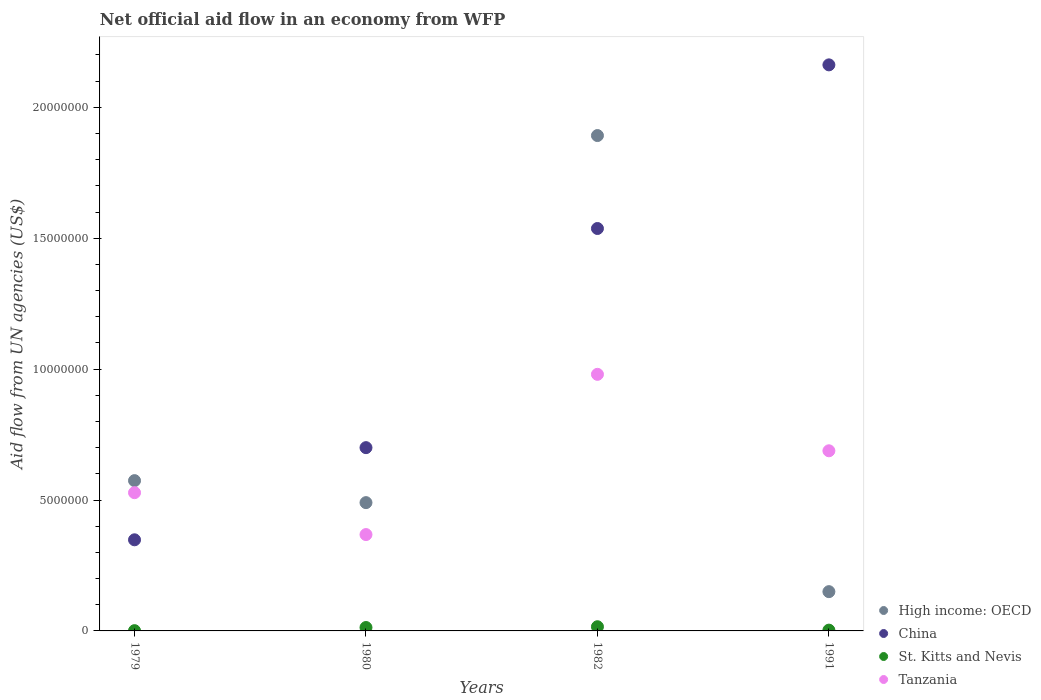How many different coloured dotlines are there?
Provide a succinct answer. 4. Is the number of dotlines equal to the number of legend labels?
Keep it short and to the point. Yes. What is the net official aid flow in China in 1991?
Make the answer very short. 2.16e+07. Across all years, what is the maximum net official aid flow in High income: OECD?
Ensure brevity in your answer.  1.89e+07. What is the total net official aid flow in Tanzania in the graph?
Your response must be concise. 2.56e+07. What is the difference between the net official aid flow in High income: OECD in 1979 and that in 1980?
Provide a succinct answer. 8.40e+05. What is the difference between the net official aid flow in High income: OECD in 1979 and the net official aid flow in China in 1980?
Your response must be concise. -1.26e+06. What is the average net official aid flow in China per year?
Offer a very short reply. 1.19e+07. In the year 1980, what is the difference between the net official aid flow in China and net official aid flow in High income: OECD?
Offer a terse response. 2.10e+06. In how many years, is the net official aid flow in St. Kitts and Nevis greater than 15000000 US$?
Make the answer very short. 0. What is the ratio of the net official aid flow in High income: OECD in 1980 to that in 1982?
Offer a terse response. 0.26. Is the difference between the net official aid flow in China in 1979 and 1982 greater than the difference between the net official aid flow in High income: OECD in 1979 and 1982?
Offer a terse response. Yes. What is the difference between the highest and the second highest net official aid flow in Tanzania?
Provide a short and direct response. 2.92e+06. What is the difference between the highest and the lowest net official aid flow in High income: OECD?
Your answer should be very brief. 1.74e+07. Is the sum of the net official aid flow in High income: OECD in 1982 and 1991 greater than the maximum net official aid flow in Tanzania across all years?
Ensure brevity in your answer.  Yes. Is it the case that in every year, the sum of the net official aid flow in St. Kitts and Nevis and net official aid flow in High income: OECD  is greater than the sum of net official aid flow in China and net official aid flow in Tanzania?
Your answer should be compact. No. Is it the case that in every year, the sum of the net official aid flow in High income: OECD and net official aid flow in Tanzania  is greater than the net official aid flow in China?
Provide a succinct answer. No. Does the net official aid flow in High income: OECD monotonically increase over the years?
Provide a short and direct response. No. How many dotlines are there?
Provide a short and direct response. 4. How many years are there in the graph?
Provide a succinct answer. 4. What is the difference between two consecutive major ticks on the Y-axis?
Your response must be concise. 5.00e+06. Where does the legend appear in the graph?
Make the answer very short. Bottom right. How are the legend labels stacked?
Provide a succinct answer. Vertical. What is the title of the graph?
Provide a short and direct response. Net official aid flow in an economy from WFP. What is the label or title of the X-axis?
Offer a terse response. Years. What is the label or title of the Y-axis?
Offer a very short reply. Aid flow from UN agencies (US$). What is the Aid flow from UN agencies (US$) of High income: OECD in 1979?
Ensure brevity in your answer.  5.74e+06. What is the Aid flow from UN agencies (US$) of China in 1979?
Provide a short and direct response. 3.48e+06. What is the Aid flow from UN agencies (US$) of Tanzania in 1979?
Keep it short and to the point. 5.28e+06. What is the Aid flow from UN agencies (US$) of High income: OECD in 1980?
Offer a terse response. 4.90e+06. What is the Aid flow from UN agencies (US$) of Tanzania in 1980?
Your answer should be compact. 3.68e+06. What is the Aid flow from UN agencies (US$) of High income: OECD in 1982?
Give a very brief answer. 1.89e+07. What is the Aid flow from UN agencies (US$) of China in 1982?
Your answer should be very brief. 1.54e+07. What is the Aid flow from UN agencies (US$) in St. Kitts and Nevis in 1982?
Offer a terse response. 1.60e+05. What is the Aid flow from UN agencies (US$) in Tanzania in 1982?
Provide a succinct answer. 9.80e+06. What is the Aid flow from UN agencies (US$) of High income: OECD in 1991?
Give a very brief answer. 1.50e+06. What is the Aid flow from UN agencies (US$) in China in 1991?
Provide a succinct answer. 2.16e+07. What is the Aid flow from UN agencies (US$) in St. Kitts and Nevis in 1991?
Keep it short and to the point. 3.00e+04. What is the Aid flow from UN agencies (US$) of Tanzania in 1991?
Your answer should be compact. 6.88e+06. Across all years, what is the maximum Aid flow from UN agencies (US$) in High income: OECD?
Your response must be concise. 1.89e+07. Across all years, what is the maximum Aid flow from UN agencies (US$) of China?
Provide a succinct answer. 2.16e+07. Across all years, what is the maximum Aid flow from UN agencies (US$) in St. Kitts and Nevis?
Provide a succinct answer. 1.60e+05. Across all years, what is the maximum Aid flow from UN agencies (US$) of Tanzania?
Give a very brief answer. 9.80e+06. Across all years, what is the minimum Aid flow from UN agencies (US$) in High income: OECD?
Offer a terse response. 1.50e+06. Across all years, what is the minimum Aid flow from UN agencies (US$) of China?
Give a very brief answer. 3.48e+06. Across all years, what is the minimum Aid flow from UN agencies (US$) of St. Kitts and Nevis?
Provide a succinct answer. 10000. Across all years, what is the minimum Aid flow from UN agencies (US$) of Tanzania?
Your response must be concise. 3.68e+06. What is the total Aid flow from UN agencies (US$) of High income: OECD in the graph?
Make the answer very short. 3.11e+07. What is the total Aid flow from UN agencies (US$) in China in the graph?
Keep it short and to the point. 4.75e+07. What is the total Aid flow from UN agencies (US$) of Tanzania in the graph?
Make the answer very short. 2.56e+07. What is the difference between the Aid flow from UN agencies (US$) of High income: OECD in 1979 and that in 1980?
Provide a short and direct response. 8.40e+05. What is the difference between the Aid flow from UN agencies (US$) in China in 1979 and that in 1980?
Make the answer very short. -3.52e+06. What is the difference between the Aid flow from UN agencies (US$) in Tanzania in 1979 and that in 1980?
Provide a succinct answer. 1.60e+06. What is the difference between the Aid flow from UN agencies (US$) in High income: OECD in 1979 and that in 1982?
Offer a very short reply. -1.32e+07. What is the difference between the Aid flow from UN agencies (US$) in China in 1979 and that in 1982?
Your answer should be very brief. -1.19e+07. What is the difference between the Aid flow from UN agencies (US$) of St. Kitts and Nevis in 1979 and that in 1982?
Ensure brevity in your answer.  -1.50e+05. What is the difference between the Aid flow from UN agencies (US$) of Tanzania in 1979 and that in 1982?
Your answer should be compact. -4.52e+06. What is the difference between the Aid flow from UN agencies (US$) in High income: OECD in 1979 and that in 1991?
Offer a very short reply. 4.24e+06. What is the difference between the Aid flow from UN agencies (US$) in China in 1979 and that in 1991?
Make the answer very short. -1.81e+07. What is the difference between the Aid flow from UN agencies (US$) in Tanzania in 1979 and that in 1991?
Keep it short and to the point. -1.60e+06. What is the difference between the Aid flow from UN agencies (US$) of High income: OECD in 1980 and that in 1982?
Ensure brevity in your answer.  -1.40e+07. What is the difference between the Aid flow from UN agencies (US$) of China in 1980 and that in 1982?
Your answer should be compact. -8.37e+06. What is the difference between the Aid flow from UN agencies (US$) in St. Kitts and Nevis in 1980 and that in 1982?
Offer a very short reply. -3.00e+04. What is the difference between the Aid flow from UN agencies (US$) of Tanzania in 1980 and that in 1982?
Provide a short and direct response. -6.12e+06. What is the difference between the Aid flow from UN agencies (US$) in High income: OECD in 1980 and that in 1991?
Ensure brevity in your answer.  3.40e+06. What is the difference between the Aid flow from UN agencies (US$) in China in 1980 and that in 1991?
Provide a short and direct response. -1.46e+07. What is the difference between the Aid flow from UN agencies (US$) in Tanzania in 1980 and that in 1991?
Keep it short and to the point. -3.20e+06. What is the difference between the Aid flow from UN agencies (US$) in High income: OECD in 1982 and that in 1991?
Your response must be concise. 1.74e+07. What is the difference between the Aid flow from UN agencies (US$) of China in 1982 and that in 1991?
Your response must be concise. -6.25e+06. What is the difference between the Aid flow from UN agencies (US$) of St. Kitts and Nevis in 1982 and that in 1991?
Make the answer very short. 1.30e+05. What is the difference between the Aid flow from UN agencies (US$) in Tanzania in 1982 and that in 1991?
Your response must be concise. 2.92e+06. What is the difference between the Aid flow from UN agencies (US$) of High income: OECD in 1979 and the Aid flow from UN agencies (US$) of China in 1980?
Offer a very short reply. -1.26e+06. What is the difference between the Aid flow from UN agencies (US$) of High income: OECD in 1979 and the Aid flow from UN agencies (US$) of St. Kitts and Nevis in 1980?
Provide a short and direct response. 5.61e+06. What is the difference between the Aid flow from UN agencies (US$) in High income: OECD in 1979 and the Aid flow from UN agencies (US$) in Tanzania in 1980?
Offer a terse response. 2.06e+06. What is the difference between the Aid flow from UN agencies (US$) of China in 1979 and the Aid flow from UN agencies (US$) of St. Kitts and Nevis in 1980?
Give a very brief answer. 3.35e+06. What is the difference between the Aid flow from UN agencies (US$) of St. Kitts and Nevis in 1979 and the Aid flow from UN agencies (US$) of Tanzania in 1980?
Keep it short and to the point. -3.67e+06. What is the difference between the Aid flow from UN agencies (US$) in High income: OECD in 1979 and the Aid flow from UN agencies (US$) in China in 1982?
Give a very brief answer. -9.63e+06. What is the difference between the Aid flow from UN agencies (US$) of High income: OECD in 1979 and the Aid flow from UN agencies (US$) of St. Kitts and Nevis in 1982?
Your response must be concise. 5.58e+06. What is the difference between the Aid flow from UN agencies (US$) in High income: OECD in 1979 and the Aid flow from UN agencies (US$) in Tanzania in 1982?
Offer a terse response. -4.06e+06. What is the difference between the Aid flow from UN agencies (US$) in China in 1979 and the Aid flow from UN agencies (US$) in St. Kitts and Nevis in 1982?
Your answer should be compact. 3.32e+06. What is the difference between the Aid flow from UN agencies (US$) in China in 1979 and the Aid flow from UN agencies (US$) in Tanzania in 1982?
Provide a short and direct response. -6.32e+06. What is the difference between the Aid flow from UN agencies (US$) of St. Kitts and Nevis in 1979 and the Aid flow from UN agencies (US$) of Tanzania in 1982?
Make the answer very short. -9.79e+06. What is the difference between the Aid flow from UN agencies (US$) of High income: OECD in 1979 and the Aid flow from UN agencies (US$) of China in 1991?
Your answer should be very brief. -1.59e+07. What is the difference between the Aid flow from UN agencies (US$) of High income: OECD in 1979 and the Aid flow from UN agencies (US$) of St. Kitts and Nevis in 1991?
Keep it short and to the point. 5.71e+06. What is the difference between the Aid flow from UN agencies (US$) in High income: OECD in 1979 and the Aid flow from UN agencies (US$) in Tanzania in 1991?
Ensure brevity in your answer.  -1.14e+06. What is the difference between the Aid flow from UN agencies (US$) in China in 1979 and the Aid flow from UN agencies (US$) in St. Kitts and Nevis in 1991?
Keep it short and to the point. 3.45e+06. What is the difference between the Aid flow from UN agencies (US$) of China in 1979 and the Aid flow from UN agencies (US$) of Tanzania in 1991?
Give a very brief answer. -3.40e+06. What is the difference between the Aid flow from UN agencies (US$) in St. Kitts and Nevis in 1979 and the Aid flow from UN agencies (US$) in Tanzania in 1991?
Give a very brief answer. -6.87e+06. What is the difference between the Aid flow from UN agencies (US$) of High income: OECD in 1980 and the Aid flow from UN agencies (US$) of China in 1982?
Your response must be concise. -1.05e+07. What is the difference between the Aid flow from UN agencies (US$) in High income: OECD in 1980 and the Aid flow from UN agencies (US$) in St. Kitts and Nevis in 1982?
Keep it short and to the point. 4.74e+06. What is the difference between the Aid flow from UN agencies (US$) of High income: OECD in 1980 and the Aid flow from UN agencies (US$) of Tanzania in 1982?
Provide a short and direct response. -4.90e+06. What is the difference between the Aid flow from UN agencies (US$) in China in 1980 and the Aid flow from UN agencies (US$) in St. Kitts and Nevis in 1982?
Provide a short and direct response. 6.84e+06. What is the difference between the Aid flow from UN agencies (US$) in China in 1980 and the Aid flow from UN agencies (US$) in Tanzania in 1982?
Offer a very short reply. -2.80e+06. What is the difference between the Aid flow from UN agencies (US$) of St. Kitts and Nevis in 1980 and the Aid flow from UN agencies (US$) of Tanzania in 1982?
Your answer should be very brief. -9.67e+06. What is the difference between the Aid flow from UN agencies (US$) in High income: OECD in 1980 and the Aid flow from UN agencies (US$) in China in 1991?
Give a very brief answer. -1.67e+07. What is the difference between the Aid flow from UN agencies (US$) in High income: OECD in 1980 and the Aid flow from UN agencies (US$) in St. Kitts and Nevis in 1991?
Offer a very short reply. 4.87e+06. What is the difference between the Aid flow from UN agencies (US$) of High income: OECD in 1980 and the Aid flow from UN agencies (US$) of Tanzania in 1991?
Give a very brief answer. -1.98e+06. What is the difference between the Aid flow from UN agencies (US$) in China in 1980 and the Aid flow from UN agencies (US$) in St. Kitts and Nevis in 1991?
Your response must be concise. 6.97e+06. What is the difference between the Aid flow from UN agencies (US$) of St. Kitts and Nevis in 1980 and the Aid flow from UN agencies (US$) of Tanzania in 1991?
Make the answer very short. -6.75e+06. What is the difference between the Aid flow from UN agencies (US$) in High income: OECD in 1982 and the Aid flow from UN agencies (US$) in China in 1991?
Keep it short and to the point. -2.70e+06. What is the difference between the Aid flow from UN agencies (US$) of High income: OECD in 1982 and the Aid flow from UN agencies (US$) of St. Kitts and Nevis in 1991?
Keep it short and to the point. 1.89e+07. What is the difference between the Aid flow from UN agencies (US$) of High income: OECD in 1982 and the Aid flow from UN agencies (US$) of Tanzania in 1991?
Your response must be concise. 1.20e+07. What is the difference between the Aid flow from UN agencies (US$) in China in 1982 and the Aid flow from UN agencies (US$) in St. Kitts and Nevis in 1991?
Ensure brevity in your answer.  1.53e+07. What is the difference between the Aid flow from UN agencies (US$) of China in 1982 and the Aid flow from UN agencies (US$) of Tanzania in 1991?
Give a very brief answer. 8.49e+06. What is the difference between the Aid flow from UN agencies (US$) in St. Kitts and Nevis in 1982 and the Aid flow from UN agencies (US$) in Tanzania in 1991?
Offer a very short reply. -6.72e+06. What is the average Aid flow from UN agencies (US$) in High income: OECD per year?
Your answer should be compact. 7.76e+06. What is the average Aid flow from UN agencies (US$) of China per year?
Provide a succinct answer. 1.19e+07. What is the average Aid flow from UN agencies (US$) in St. Kitts and Nevis per year?
Make the answer very short. 8.25e+04. What is the average Aid flow from UN agencies (US$) of Tanzania per year?
Keep it short and to the point. 6.41e+06. In the year 1979, what is the difference between the Aid flow from UN agencies (US$) in High income: OECD and Aid flow from UN agencies (US$) in China?
Your answer should be very brief. 2.26e+06. In the year 1979, what is the difference between the Aid flow from UN agencies (US$) in High income: OECD and Aid flow from UN agencies (US$) in St. Kitts and Nevis?
Provide a short and direct response. 5.73e+06. In the year 1979, what is the difference between the Aid flow from UN agencies (US$) in China and Aid flow from UN agencies (US$) in St. Kitts and Nevis?
Your answer should be compact. 3.47e+06. In the year 1979, what is the difference between the Aid flow from UN agencies (US$) of China and Aid flow from UN agencies (US$) of Tanzania?
Provide a short and direct response. -1.80e+06. In the year 1979, what is the difference between the Aid flow from UN agencies (US$) of St. Kitts and Nevis and Aid flow from UN agencies (US$) of Tanzania?
Ensure brevity in your answer.  -5.27e+06. In the year 1980, what is the difference between the Aid flow from UN agencies (US$) of High income: OECD and Aid flow from UN agencies (US$) of China?
Offer a terse response. -2.10e+06. In the year 1980, what is the difference between the Aid flow from UN agencies (US$) of High income: OECD and Aid flow from UN agencies (US$) of St. Kitts and Nevis?
Provide a succinct answer. 4.77e+06. In the year 1980, what is the difference between the Aid flow from UN agencies (US$) in High income: OECD and Aid flow from UN agencies (US$) in Tanzania?
Make the answer very short. 1.22e+06. In the year 1980, what is the difference between the Aid flow from UN agencies (US$) in China and Aid flow from UN agencies (US$) in St. Kitts and Nevis?
Make the answer very short. 6.87e+06. In the year 1980, what is the difference between the Aid flow from UN agencies (US$) of China and Aid flow from UN agencies (US$) of Tanzania?
Provide a short and direct response. 3.32e+06. In the year 1980, what is the difference between the Aid flow from UN agencies (US$) in St. Kitts and Nevis and Aid flow from UN agencies (US$) in Tanzania?
Give a very brief answer. -3.55e+06. In the year 1982, what is the difference between the Aid flow from UN agencies (US$) of High income: OECD and Aid flow from UN agencies (US$) of China?
Offer a terse response. 3.55e+06. In the year 1982, what is the difference between the Aid flow from UN agencies (US$) in High income: OECD and Aid flow from UN agencies (US$) in St. Kitts and Nevis?
Keep it short and to the point. 1.88e+07. In the year 1982, what is the difference between the Aid flow from UN agencies (US$) of High income: OECD and Aid flow from UN agencies (US$) of Tanzania?
Offer a very short reply. 9.12e+06. In the year 1982, what is the difference between the Aid flow from UN agencies (US$) of China and Aid flow from UN agencies (US$) of St. Kitts and Nevis?
Provide a succinct answer. 1.52e+07. In the year 1982, what is the difference between the Aid flow from UN agencies (US$) of China and Aid flow from UN agencies (US$) of Tanzania?
Provide a succinct answer. 5.57e+06. In the year 1982, what is the difference between the Aid flow from UN agencies (US$) in St. Kitts and Nevis and Aid flow from UN agencies (US$) in Tanzania?
Make the answer very short. -9.64e+06. In the year 1991, what is the difference between the Aid flow from UN agencies (US$) in High income: OECD and Aid flow from UN agencies (US$) in China?
Keep it short and to the point. -2.01e+07. In the year 1991, what is the difference between the Aid flow from UN agencies (US$) of High income: OECD and Aid flow from UN agencies (US$) of St. Kitts and Nevis?
Offer a very short reply. 1.47e+06. In the year 1991, what is the difference between the Aid flow from UN agencies (US$) in High income: OECD and Aid flow from UN agencies (US$) in Tanzania?
Provide a short and direct response. -5.38e+06. In the year 1991, what is the difference between the Aid flow from UN agencies (US$) in China and Aid flow from UN agencies (US$) in St. Kitts and Nevis?
Provide a succinct answer. 2.16e+07. In the year 1991, what is the difference between the Aid flow from UN agencies (US$) of China and Aid flow from UN agencies (US$) of Tanzania?
Give a very brief answer. 1.47e+07. In the year 1991, what is the difference between the Aid flow from UN agencies (US$) of St. Kitts and Nevis and Aid flow from UN agencies (US$) of Tanzania?
Keep it short and to the point. -6.85e+06. What is the ratio of the Aid flow from UN agencies (US$) of High income: OECD in 1979 to that in 1980?
Give a very brief answer. 1.17. What is the ratio of the Aid flow from UN agencies (US$) in China in 1979 to that in 1980?
Ensure brevity in your answer.  0.5. What is the ratio of the Aid flow from UN agencies (US$) in St. Kitts and Nevis in 1979 to that in 1980?
Your response must be concise. 0.08. What is the ratio of the Aid flow from UN agencies (US$) in Tanzania in 1979 to that in 1980?
Your answer should be very brief. 1.43. What is the ratio of the Aid flow from UN agencies (US$) of High income: OECD in 1979 to that in 1982?
Keep it short and to the point. 0.3. What is the ratio of the Aid flow from UN agencies (US$) in China in 1979 to that in 1982?
Your answer should be compact. 0.23. What is the ratio of the Aid flow from UN agencies (US$) of St. Kitts and Nevis in 1979 to that in 1982?
Make the answer very short. 0.06. What is the ratio of the Aid flow from UN agencies (US$) in Tanzania in 1979 to that in 1982?
Give a very brief answer. 0.54. What is the ratio of the Aid flow from UN agencies (US$) of High income: OECD in 1979 to that in 1991?
Offer a terse response. 3.83. What is the ratio of the Aid flow from UN agencies (US$) in China in 1979 to that in 1991?
Offer a terse response. 0.16. What is the ratio of the Aid flow from UN agencies (US$) in St. Kitts and Nevis in 1979 to that in 1991?
Offer a terse response. 0.33. What is the ratio of the Aid flow from UN agencies (US$) of Tanzania in 1979 to that in 1991?
Keep it short and to the point. 0.77. What is the ratio of the Aid flow from UN agencies (US$) of High income: OECD in 1980 to that in 1982?
Ensure brevity in your answer.  0.26. What is the ratio of the Aid flow from UN agencies (US$) in China in 1980 to that in 1982?
Offer a terse response. 0.46. What is the ratio of the Aid flow from UN agencies (US$) in St. Kitts and Nevis in 1980 to that in 1982?
Provide a succinct answer. 0.81. What is the ratio of the Aid flow from UN agencies (US$) in Tanzania in 1980 to that in 1982?
Keep it short and to the point. 0.38. What is the ratio of the Aid flow from UN agencies (US$) of High income: OECD in 1980 to that in 1991?
Your answer should be very brief. 3.27. What is the ratio of the Aid flow from UN agencies (US$) of China in 1980 to that in 1991?
Provide a short and direct response. 0.32. What is the ratio of the Aid flow from UN agencies (US$) in St. Kitts and Nevis in 1980 to that in 1991?
Your answer should be compact. 4.33. What is the ratio of the Aid flow from UN agencies (US$) in Tanzania in 1980 to that in 1991?
Give a very brief answer. 0.53. What is the ratio of the Aid flow from UN agencies (US$) in High income: OECD in 1982 to that in 1991?
Keep it short and to the point. 12.61. What is the ratio of the Aid flow from UN agencies (US$) in China in 1982 to that in 1991?
Offer a terse response. 0.71. What is the ratio of the Aid flow from UN agencies (US$) in St. Kitts and Nevis in 1982 to that in 1991?
Your response must be concise. 5.33. What is the ratio of the Aid flow from UN agencies (US$) in Tanzania in 1982 to that in 1991?
Your response must be concise. 1.42. What is the difference between the highest and the second highest Aid flow from UN agencies (US$) in High income: OECD?
Your answer should be very brief. 1.32e+07. What is the difference between the highest and the second highest Aid flow from UN agencies (US$) in China?
Your answer should be compact. 6.25e+06. What is the difference between the highest and the second highest Aid flow from UN agencies (US$) in Tanzania?
Your answer should be very brief. 2.92e+06. What is the difference between the highest and the lowest Aid flow from UN agencies (US$) in High income: OECD?
Provide a short and direct response. 1.74e+07. What is the difference between the highest and the lowest Aid flow from UN agencies (US$) in China?
Your answer should be compact. 1.81e+07. What is the difference between the highest and the lowest Aid flow from UN agencies (US$) in Tanzania?
Make the answer very short. 6.12e+06. 